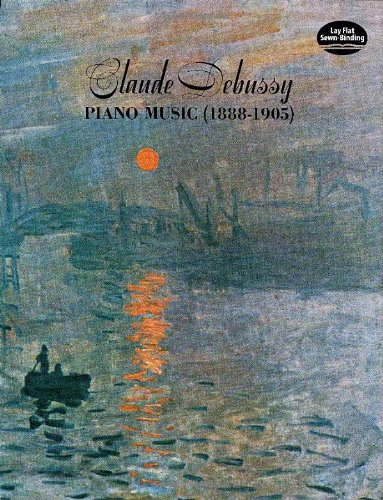Who is the author of this book? The author of the book is Claude Debussy, a prominent French composer known for his influential piano compositions in the Impressionist era. 